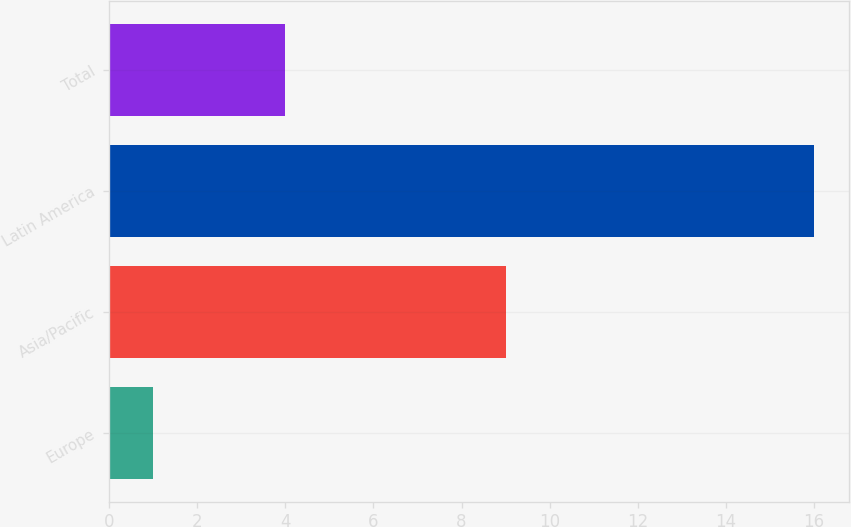Convert chart. <chart><loc_0><loc_0><loc_500><loc_500><bar_chart><fcel>Europe<fcel>Asia/Pacific<fcel>Latin America<fcel>Total<nl><fcel>1<fcel>9<fcel>16<fcel>4<nl></chart> 